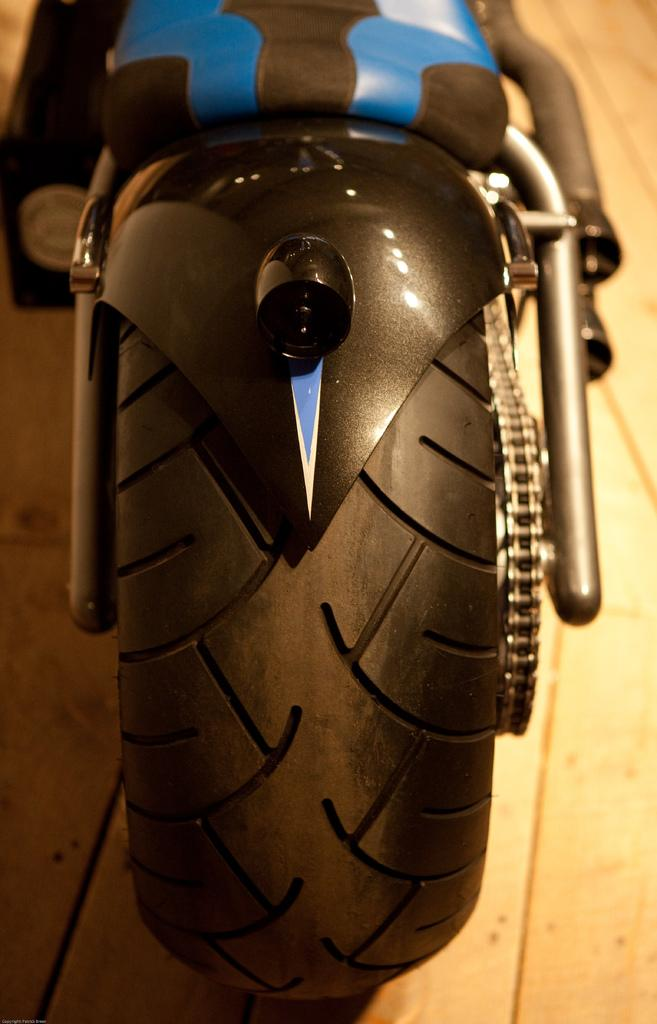What is the main object in the image? There is a bike in the image. What color are the wheels of the bike? The bike has black-colored wheels. Does the bike have any additional features? Yes, the bike has a chain. Where is the bike located in the image? The bike is on a surface. How would you describe the background of the image? The background of the image is blurred. How many crackers are on the bike in the image? There are no crackers present in the image; it only features a bike with black-colored wheels, a chain, and a blurred background. Are there any chairs visible in the image? There are no chairs present in the image; it only features a bike with black-colored wheels, a chain, and a blurred background. 